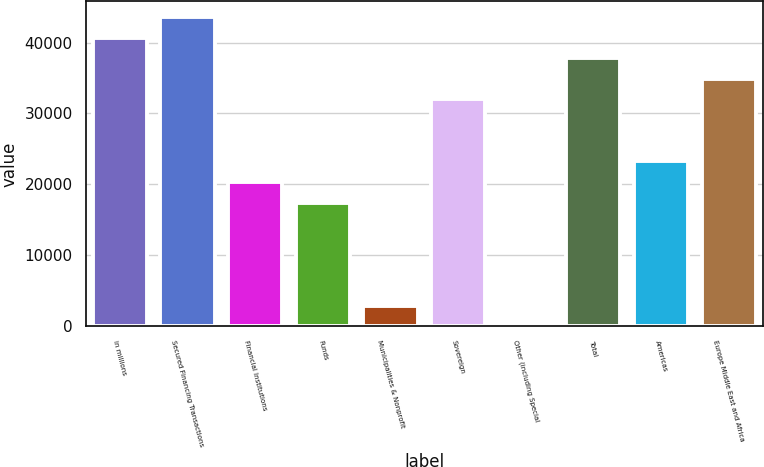Convert chart to OTSL. <chart><loc_0><loc_0><loc_500><loc_500><bar_chart><fcel>in millions<fcel>Secured Financing Transactions<fcel>Financial Institutions<fcel>Funds<fcel>Municipalities & Nonprofit<fcel>Sovereign<fcel>Other (including Special<fcel>Total<fcel>Americas<fcel>Europe Middle East and Africa<nl><fcel>40699<fcel>43606<fcel>20350<fcel>17443<fcel>2908<fcel>31978<fcel>1<fcel>37792<fcel>23257<fcel>34885<nl></chart> 